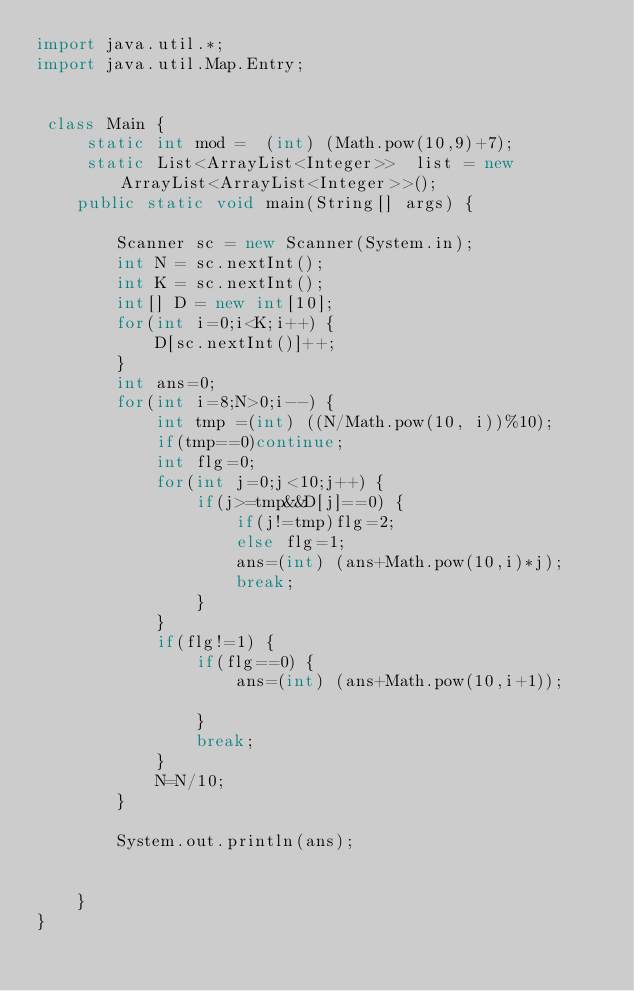<code> <loc_0><loc_0><loc_500><loc_500><_Java_>import java.util.*;
import java.util.Map.Entry;
 
 
 class Main {
	 static int mod =  (int) (Math.pow(10,9)+7);
	 static List<ArrayList<Integer>>  list = new ArrayList<ArrayList<Integer>>();
    public static void main(String[] args) {
    
        Scanner sc = new Scanner(System.in);
    	int N = sc.nextInt();
    	int K = sc.nextInt();
    	int[] D = new int[10];
    	for(int i=0;i<K;i++) {
    		D[sc.nextInt()]++;
    	}
    	int ans=0;
    	for(int i=8;N>0;i--) {
    		int tmp =(int) ((N/Math.pow(10, i))%10);
    		if(tmp==0)continue;
    		int flg=0;
    		for(int j=0;j<10;j++) {
    			if(j>=tmp&&D[j]==0) {
    				if(j!=tmp)flg=2;
    				else flg=1;
    				ans=(int) (ans+Math.pow(10,i)*j);
    				break;
    			}
    		}
    		if(flg!=1) {
    			if(flg==0) {
        			ans=(int) (ans+Math.pow(10,i+1));    				
    			}
    			break;
    		}
    		N=N/10;
    	}
    	
        System.out.println(ans);
        
        		
    }
}</code> 